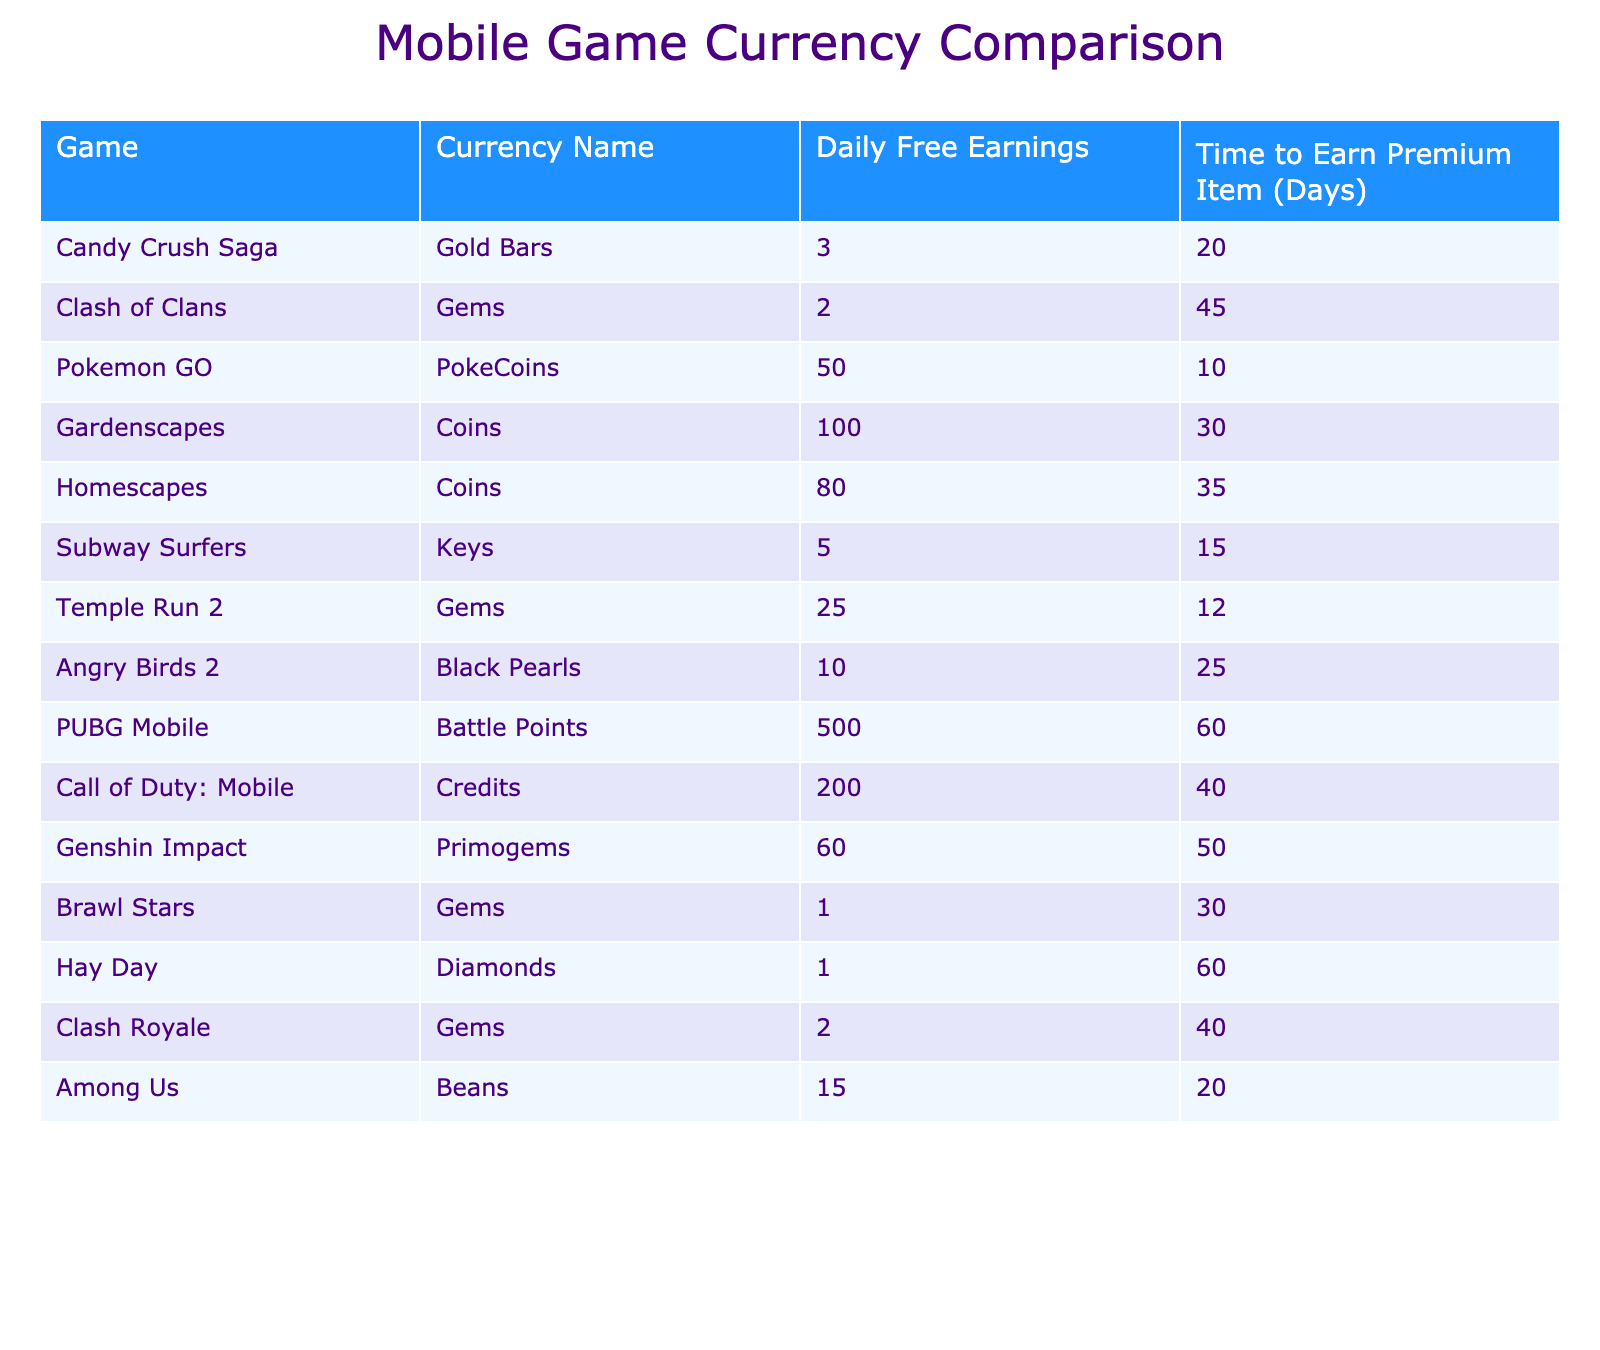What is the daily free earning rate of Pokemon GO? The table shows a specific column for daily free earnings, and for Pokemon GO, it indicates 50 PokeCoins.
Answer: 50 PokeCoins Which game has the highest daily free earnings? By reviewing the daily free earnings column, Gardenscapes has 100 Coins, which is the highest among all the games listed.
Answer: Gardenscapes How many days does it take to earn a premium item in Subway Surfers? The time to earn a premium item for Subway Surfers is clearly indicated in the table as 15 days.
Answer: 15 days What is the difference in daily earnings between Candy Crush Saga and Clash Royale? Candy Crush Saga earns 3 Gold Bars daily, and Clash Royale earns 2 Gems daily. The difference is 3 - 2 = 1.
Answer: 1 Which game requires the longest time to earn a premium item? Looking at the "Time to Earn Premium Item" column shows that PUBG Mobile requires 60 days, which is the longest listed time.
Answer: PUBG Mobile Is it true that Angry Birds 2 has higher daily earnings than Clash of Clans? Angry Birds 2 earns 10 Black Pearls daily, while Clash of Clans earns 2 Gems daily. Since 10 is greater than 2, this statement is true.
Answer: Yes What are the average daily earnings of games that use Gems as their currency? The games using Gems are Clash of Clans (2), Temple Run 2 (25), Brawl Stars (1), and Clash Royale (2). The average is calculated as (2 + 25 + 1 + 2) / 4 = 7.5.
Answer: 7.5 How many days does it take in total to earn a premium item in both Genshin Impact and Call of Duty: Mobile? Genshin Impact takes 50 days and Call of Duty: Mobile takes 40 days. Adding these together gives 50 + 40 = 90 days total.
Answer: 90 days Among the listed games, which has the highest earnings and the shortest time to earn a premium item? Gardenscapes has the highest daily earning of 100 Coins and it takes 30 days to earn a premium item, which is shorter than some others with similar high earnings.
Answer: Gardenscapes Can you list any two games that provide more than 50 daily earnings? Both Pokemon GO (50) and Gardenscapes (100) provide more than 50 daily earnings.
Answer: Pokemon GO and Gardenscapes 